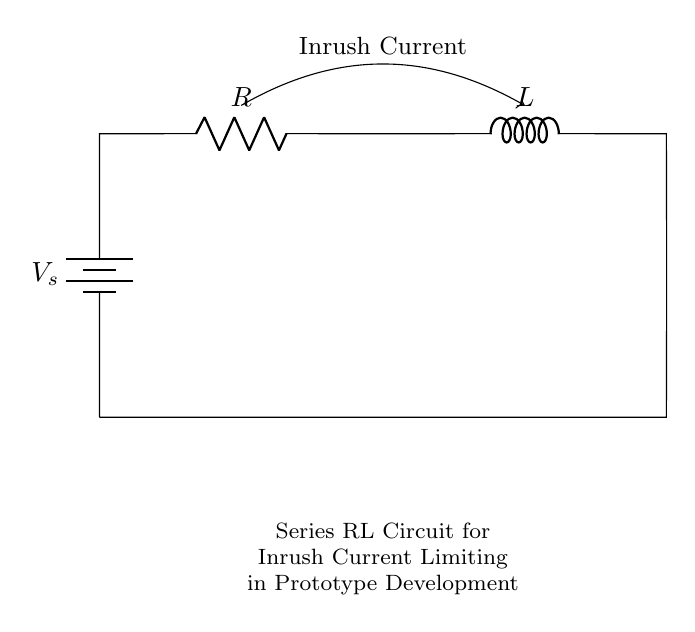What is the source voltage in the circuit? The source voltage, labeled as V_s, is the voltage provided by the battery in the circuit diagram.
Answer: V_s What are the components connected in series? The components in series are the resistor (R) and inductor (L), as they are connected one after the other in the same pathway for current.
Answer: Resistor and Inductor What is the purpose of the inrush current arrow in the diagram? The inrush current arrow indicates the direction of the initial surge of current that occurs when the circuit is powered on, which is an important aspect to be aware of in prototype development.
Answer: Indicating initial surge How does the inductor affect the current in the circuit? An inductor opposes changes in current due to its property of inductance, limiting the rate of increase of current during the inrush period, thus protecting other components in the circuit from high currents.
Answer: Limits current change What happens to inrush current if resistance is increased? Increasing the resistance (R) in the series circuit will reduce the inrush current because according to Ohm's law, higher resistance leads to lower current for a given voltage.
Answer: Decreases inrush current What is the overall circuit type of this arrangement? This arrangement is classified as a series RL circuit, where a resistor and inductor are connected in series to control current flow.
Answer: Series RL circuit 